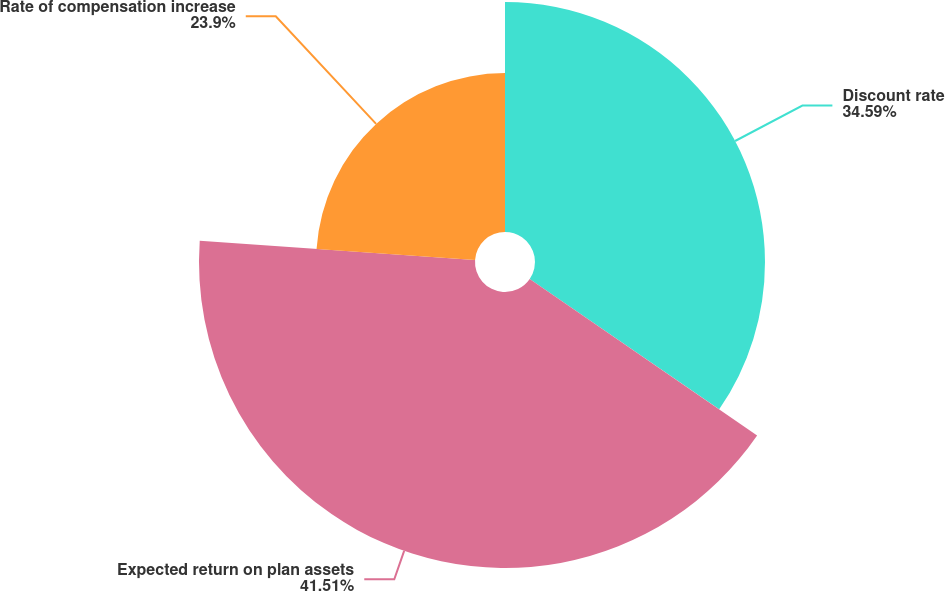<chart> <loc_0><loc_0><loc_500><loc_500><pie_chart><fcel>Discount rate<fcel>Expected return on plan assets<fcel>Rate of compensation increase<nl><fcel>34.59%<fcel>41.51%<fcel>23.9%<nl></chart> 